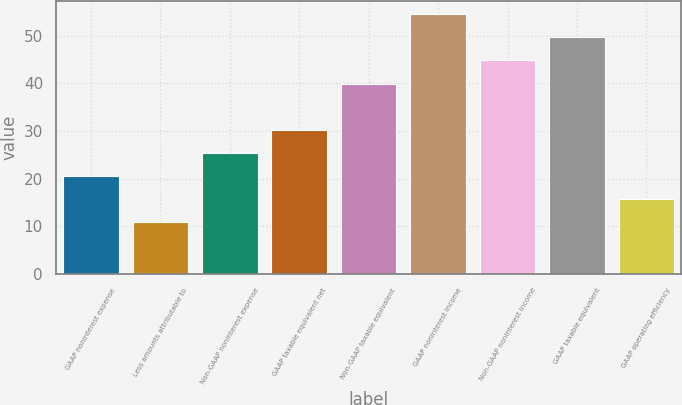Convert chart. <chart><loc_0><loc_0><loc_500><loc_500><bar_chart><fcel>GAAP noninterest expense<fcel>Less amounts attributable to<fcel>Non-GAAP noninterest expense<fcel>GAAP taxable equivalent net<fcel>Non-GAAP taxable equivalent<fcel>GAAP noninterest income<fcel>Non-GAAP noninterest income<fcel>GAAP taxable equivalent<fcel>GAAP operating efficiency<nl><fcel>20.55<fcel>10.85<fcel>25.4<fcel>30.25<fcel>39.95<fcel>54.5<fcel>44.8<fcel>49.65<fcel>15.7<nl></chart> 